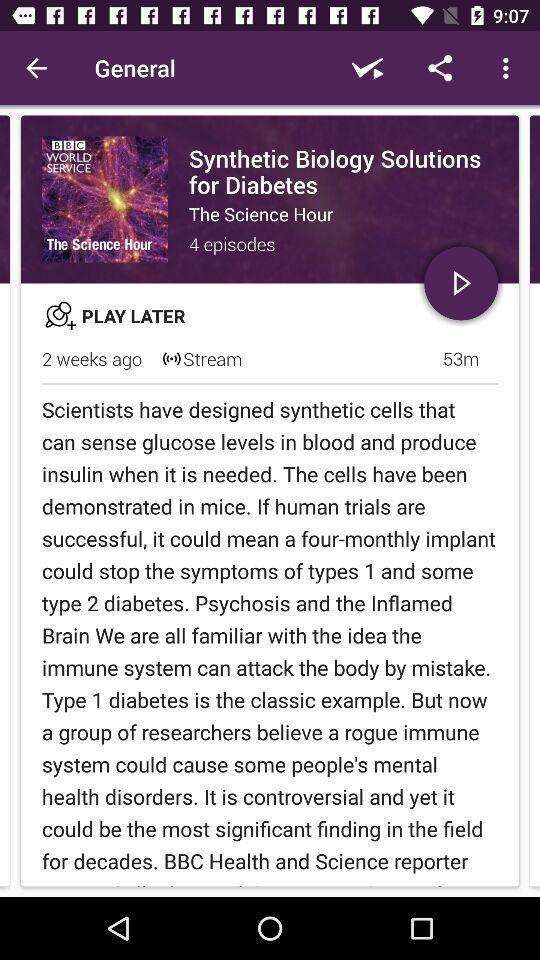How many episodes are there for the podcast 'The Science Hour'?
Answer the question using a single word or phrase. 4 